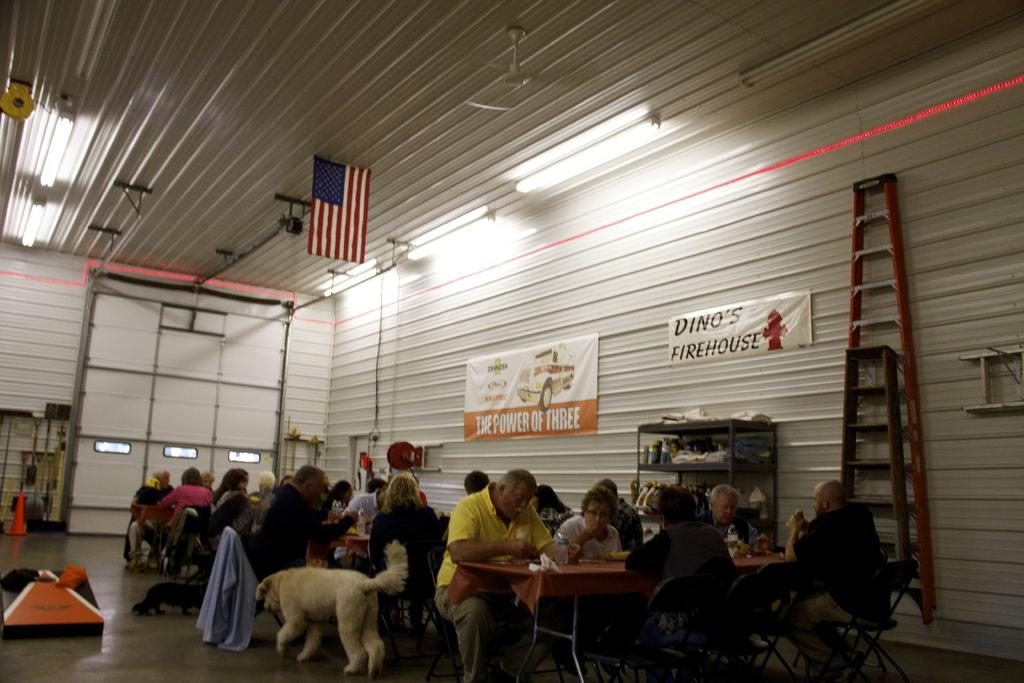What are the people in the image doing? The people in the image are seated and eating food on a table. Can you describe the presence of an animal in the image? Yes, there is a dog in the image. What decorative element is hanging from the roof in the image? There is a flag hanging from the roof in the image. What type of jam is being served to the cattle in the image? There are no cattle or jam present in the image. How many goldfish are swimming in the bowl on the table in the image? There is no bowl of goldfish present in the image. 